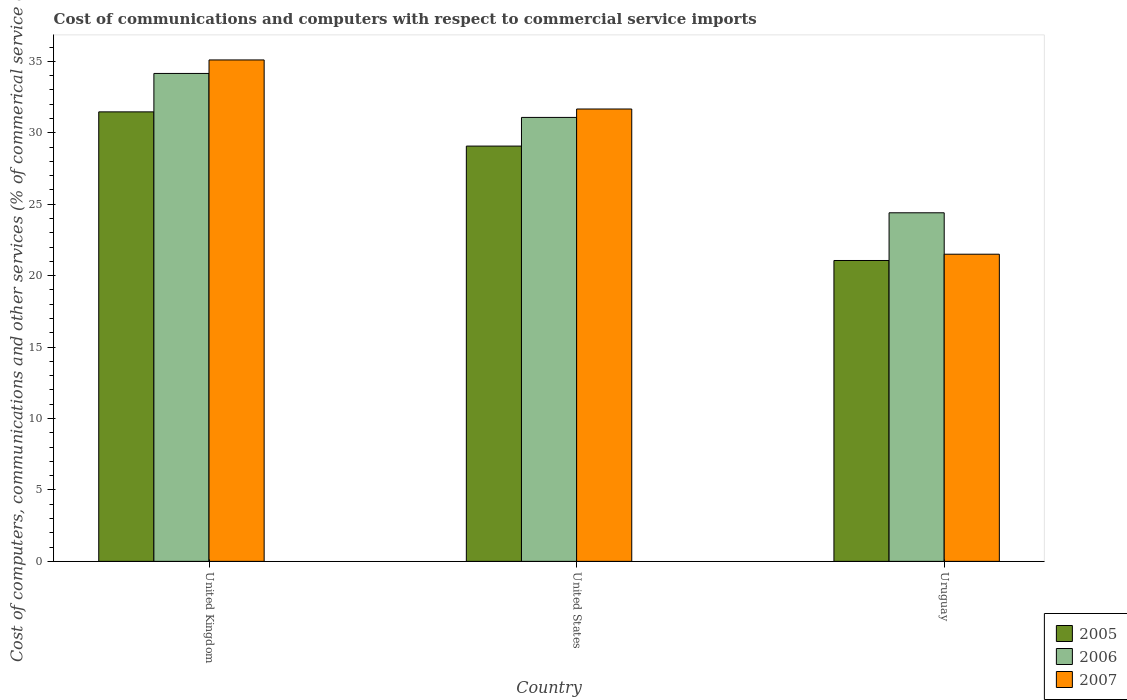How many different coloured bars are there?
Make the answer very short. 3. How many groups of bars are there?
Your answer should be compact. 3. How many bars are there on the 1st tick from the right?
Ensure brevity in your answer.  3. What is the label of the 3rd group of bars from the left?
Keep it short and to the point. Uruguay. What is the cost of communications and computers in 2007 in Uruguay?
Make the answer very short. 21.5. Across all countries, what is the maximum cost of communications and computers in 2005?
Offer a terse response. 31.47. Across all countries, what is the minimum cost of communications and computers in 2007?
Keep it short and to the point. 21.5. In which country was the cost of communications and computers in 2007 minimum?
Your answer should be compact. Uruguay. What is the total cost of communications and computers in 2007 in the graph?
Your answer should be compact. 88.27. What is the difference between the cost of communications and computers in 2006 in United Kingdom and that in Uruguay?
Provide a short and direct response. 9.75. What is the difference between the cost of communications and computers in 2006 in Uruguay and the cost of communications and computers in 2005 in United Kingdom?
Your response must be concise. -7.07. What is the average cost of communications and computers in 2005 per country?
Keep it short and to the point. 27.2. What is the difference between the cost of communications and computers of/in 2006 and cost of communications and computers of/in 2005 in United States?
Your response must be concise. 2.01. What is the ratio of the cost of communications and computers in 2005 in United Kingdom to that in United States?
Ensure brevity in your answer.  1.08. Is the cost of communications and computers in 2007 in United Kingdom less than that in Uruguay?
Give a very brief answer. No. Is the difference between the cost of communications and computers in 2006 in United Kingdom and United States greater than the difference between the cost of communications and computers in 2005 in United Kingdom and United States?
Keep it short and to the point. Yes. What is the difference between the highest and the second highest cost of communications and computers in 2007?
Your answer should be compact. 13.6. What is the difference between the highest and the lowest cost of communications and computers in 2005?
Provide a short and direct response. 10.41. In how many countries, is the cost of communications and computers in 2007 greater than the average cost of communications and computers in 2007 taken over all countries?
Give a very brief answer. 2. Is the sum of the cost of communications and computers in 2007 in United States and Uruguay greater than the maximum cost of communications and computers in 2006 across all countries?
Your answer should be very brief. Yes. What does the 3rd bar from the left in United States represents?
Keep it short and to the point. 2007. How many bars are there?
Ensure brevity in your answer.  9. Are all the bars in the graph horizontal?
Keep it short and to the point. No. Does the graph contain any zero values?
Your answer should be compact. No. Does the graph contain grids?
Ensure brevity in your answer.  No. How many legend labels are there?
Provide a succinct answer. 3. How are the legend labels stacked?
Give a very brief answer. Vertical. What is the title of the graph?
Provide a short and direct response. Cost of communications and computers with respect to commercial service imports. Does "2010" appear as one of the legend labels in the graph?
Ensure brevity in your answer.  No. What is the label or title of the X-axis?
Your response must be concise. Country. What is the label or title of the Y-axis?
Your answer should be compact. Cost of computers, communications and other services (% of commerical service exports). What is the Cost of computers, communications and other services (% of commerical service exports) in 2005 in United Kingdom?
Ensure brevity in your answer.  31.47. What is the Cost of computers, communications and other services (% of commerical service exports) of 2006 in United Kingdom?
Give a very brief answer. 34.16. What is the Cost of computers, communications and other services (% of commerical service exports) of 2007 in United Kingdom?
Offer a very short reply. 35.1. What is the Cost of computers, communications and other services (% of commerical service exports) in 2005 in United States?
Give a very brief answer. 29.07. What is the Cost of computers, communications and other services (% of commerical service exports) in 2006 in United States?
Keep it short and to the point. 31.08. What is the Cost of computers, communications and other services (% of commerical service exports) of 2007 in United States?
Make the answer very short. 31.67. What is the Cost of computers, communications and other services (% of commerical service exports) in 2005 in Uruguay?
Offer a very short reply. 21.06. What is the Cost of computers, communications and other services (% of commerical service exports) of 2006 in Uruguay?
Offer a very short reply. 24.4. What is the Cost of computers, communications and other services (% of commerical service exports) in 2007 in Uruguay?
Your response must be concise. 21.5. Across all countries, what is the maximum Cost of computers, communications and other services (% of commerical service exports) of 2005?
Your response must be concise. 31.47. Across all countries, what is the maximum Cost of computers, communications and other services (% of commerical service exports) in 2006?
Provide a short and direct response. 34.16. Across all countries, what is the maximum Cost of computers, communications and other services (% of commerical service exports) in 2007?
Your answer should be compact. 35.1. Across all countries, what is the minimum Cost of computers, communications and other services (% of commerical service exports) of 2005?
Keep it short and to the point. 21.06. Across all countries, what is the minimum Cost of computers, communications and other services (% of commerical service exports) of 2006?
Your answer should be compact. 24.4. Across all countries, what is the minimum Cost of computers, communications and other services (% of commerical service exports) in 2007?
Give a very brief answer. 21.5. What is the total Cost of computers, communications and other services (% of commerical service exports) of 2005 in the graph?
Your response must be concise. 81.6. What is the total Cost of computers, communications and other services (% of commerical service exports) in 2006 in the graph?
Provide a short and direct response. 89.64. What is the total Cost of computers, communications and other services (% of commerical service exports) in 2007 in the graph?
Your answer should be very brief. 88.27. What is the difference between the Cost of computers, communications and other services (% of commerical service exports) of 2005 in United Kingdom and that in United States?
Offer a very short reply. 2.4. What is the difference between the Cost of computers, communications and other services (% of commerical service exports) in 2006 in United Kingdom and that in United States?
Provide a succinct answer. 3.08. What is the difference between the Cost of computers, communications and other services (% of commerical service exports) in 2007 in United Kingdom and that in United States?
Offer a terse response. 3.43. What is the difference between the Cost of computers, communications and other services (% of commerical service exports) of 2005 in United Kingdom and that in Uruguay?
Provide a succinct answer. 10.41. What is the difference between the Cost of computers, communications and other services (% of commerical service exports) of 2006 in United Kingdom and that in Uruguay?
Ensure brevity in your answer.  9.75. What is the difference between the Cost of computers, communications and other services (% of commerical service exports) in 2007 in United Kingdom and that in Uruguay?
Your answer should be compact. 13.6. What is the difference between the Cost of computers, communications and other services (% of commerical service exports) in 2005 in United States and that in Uruguay?
Give a very brief answer. 8.01. What is the difference between the Cost of computers, communications and other services (% of commerical service exports) of 2006 in United States and that in Uruguay?
Make the answer very short. 6.68. What is the difference between the Cost of computers, communications and other services (% of commerical service exports) of 2007 in United States and that in Uruguay?
Ensure brevity in your answer.  10.17. What is the difference between the Cost of computers, communications and other services (% of commerical service exports) of 2005 in United Kingdom and the Cost of computers, communications and other services (% of commerical service exports) of 2006 in United States?
Make the answer very short. 0.39. What is the difference between the Cost of computers, communications and other services (% of commerical service exports) in 2005 in United Kingdom and the Cost of computers, communications and other services (% of commerical service exports) in 2007 in United States?
Provide a succinct answer. -0.2. What is the difference between the Cost of computers, communications and other services (% of commerical service exports) in 2006 in United Kingdom and the Cost of computers, communications and other services (% of commerical service exports) in 2007 in United States?
Your response must be concise. 2.49. What is the difference between the Cost of computers, communications and other services (% of commerical service exports) in 2005 in United Kingdom and the Cost of computers, communications and other services (% of commerical service exports) in 2006 in Uruguay?
Give a very brief answer. 7.07. What is the difference between the Cost of computers, communications and other services (% of commerical service exports) of 2005 in United Kingdom and the Cost of computers, communications and other services (% of commerical service exports) of 2007 in Uruguay?
Keep it short and to the point. 9.97. What is the difference between the Cost of computers, communications and other services (% of commerical service exports) of 2006 in United Kingdom and the Cost of computers, communications and other services (% of commerical service exports) of 2007 in Uruguay?
Your response must be concise. 12.65. What is the difference between the Cost of computers, communications and other services (% of commerical service exports) in 2005 in United States and the Cost of computers, communications and other services (% of commerical service exports) in 2006 in Uruguay?
Your response must be concise. 4.67. What is the difference between the Cost of computers, communications and other services (% of commerical service exports) in 2005 in United States and the Cost of computers, communications and other services (% of commerical service exports) in 2007 in Uruguay?
Give a very brief answer. 7.57. What is the difference between the Cost of computers, communications and other services (% of commerical service exports) of 2006 in United States and the Cost of computers, communications and other services (% of commerical service exports) of 2007 in Uruguay?
Offer a very short reply. 9.58. What is the average Cost of computers, communications and other services (% of commerical service exports) in 2005 per country?
Your answer should be very brief. 27.2. What is the average Cost of computers, communications and other services (% of commerical service exports) in 2006 per country?
Provide a short and direct response. 29.88. What is the average Cost of computers, communications and other services (% of commerical service exports) in 2007 per country?
Your answer should be very brief. 29.42. What is the difference between the Cost of computers, communications and other services (% of commerical service exports) in 2005 and Cost of computers, communications and other services (% of commerical service exports) in 2006 in United Kingdom?
Offer a very short reply. -2.69. What is the difference between the Cost of computers, communications and other services (% of commerical service exports) in 2005 and Cost of computers, communications and other services (% of commerical service exports) in 2007 in United Kingdom?
Keep it short and to the point. -3.63. What is the difference between the Cost of computers, communications and other services (% of commerical service exports) of 2006 and Cost of computers, communications and other services (% of commerical service exports) of 2007 in United Kingdom?
Provide a succinct answer. -0.95. What is the difference between the Cost of computers, communications and other services (% of commerical service exports) of 2005 and Cost of computers, communications and other services (% of commerical service exports) of 2006 in United States?
Your response must be concise. -2.01. What is the difference between the Cost of computers, communications and other services (% of commerical service exports) of 2005 and Cost of computers, communications and other services (% of commerical service exports) of 2007 in United States?
Offer a very short reply. -2.6. What is the difference between the Cost of computers, communications and other services (% of commerical service exports) in 2006 and Cost of computers, communications and other services (% of commerical service exports) in 2007 in United States?
Keep it short and to the point. -0.59. What is the difference between the Cost of computers, communications and other services (% of commerical service exports) of 2005 and Cost of computers, communications and other services (% of commerical service exports) of 2006 in Uruguay?
Provide a short and direct response. -3.34. What is the difference between the Cost of computers, communications and other services (% of commerical service exports) in 2005 and Cost of computers, communications and other services (% of commerical service exports) in 2007 in Uruguay?
Offer a terse response. -0.44. What is the difference between the Cost of computers, communications and other services (% of commerical service exports) of 2006 and Cost of computers, communications and other services (% of commerical service exports) of 2007 in Uruguay?
Your response must be concise. 2.9. What is the ratio of the Cost of computers, communications and other services (% of commerical service exports) of 2005 in United Kingdom to that in United States?
Offer a terse response. 1.08. What is the ratio of the Cost of computers, communications and other services (% of commerical service exports) of 2006 in United Kingdom to that in United States?
Your response must be concise. 1.1. What is the ratio of the Cost of computers, communications and other services (% of commerical service exports) of 2007 in United Kingdom to that in United States?
Offer a terse response. 1.11. What is the ratio of the Cost of computers, communications and other services (% of commerical service exports) of 2005 in United Kingdom to that in Uruguay?
Give a very brief answer. 1.49. What is the ratio of the Cost of computers, communications and other services (% of commerical service exports) of 2006 in United Kingdom to that in Uruguay?
Offer a terse response. 1.4. What is the ratio of the Cost of computers, communications and other services (% of commerical service exports) of 2007 in United Kingdom to that in Uruguay?
Offer a terse response. 1.63. What is the ratio of the Cost of computers, communications and other services (% of commerical service exports) in 2005 in United States to that in Uruguay?
Your answer should be very brief. 1.38. What is the ratio of the Cost of computers, communications and other services (% of commerical service exports) in 2006 in United States to that in Uruguay?
Make the answer very short. 1.27. What is the ratio of the Cost of computers, communications and other services (% of commerical service exports) in 2007 in United States to that in Uruguay?
Provide a short and direct response. 1.47. What is the difference between the highest and the second highest Cost of computers, communications and other services (% of commerical service exports) of 2005?
Your response must be concise. 2.4. What is the difference between the highest and the second highest Cost of computers, communications and other services (% of commerical service exports) of 2006?
Your answer should be very brief. 3.08. What is the difference between the highest and the second highest Cost of computers, communications and other services (% of commerical service exports) in 2007?
Keep it short and to the point. 3.43. What is the difference between the highest and the lowest Cost of computers, communications and other services (% of commerical service exports) of 2005?
Keep it short and to the point. 10.41. What is the difference between the highest and the lowest Cost of computers, communications and other services (% of commerical service exports) in 2006?
Your answer should be compact. 9.75. What is the difference between the highest and the lowest Cost of computers, communications and other services (% of commerical service exports) in 2007?
Your answer should be very brief. 13.6. 